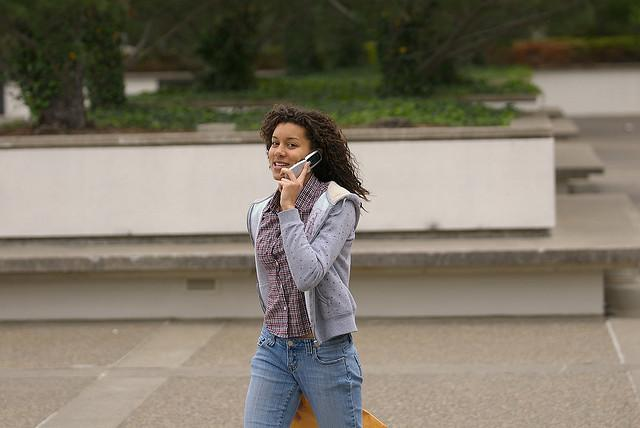How would she close the front of her sweater? zipper 